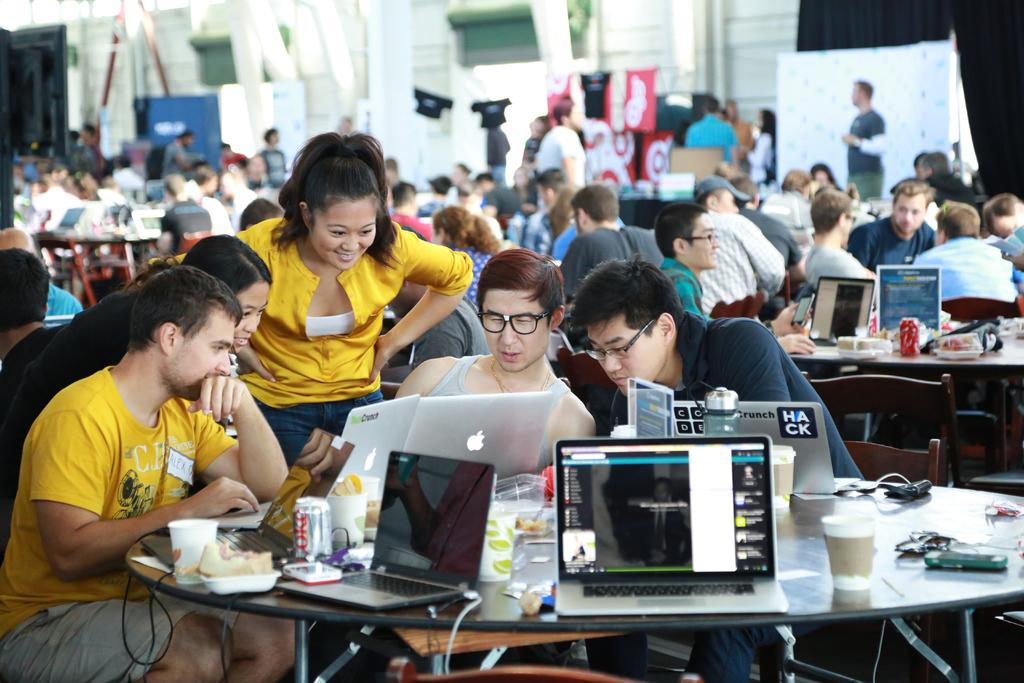How many people are in the image? There are many people in the image. What are the people doing in the image? Some people are sitting, while others are standing. What can be seen on the table in the image? Laptops, a can, snacks, and glasses are on the table. What type of furniture is present in the image? There is a table and a chair in the image. What type of ring is being worn by the person in the image? There is no ring visible on any person in the image. What type of society is being depicted in the image? The image does not depict a specific society; it simply shows people, a table, and various objects. 